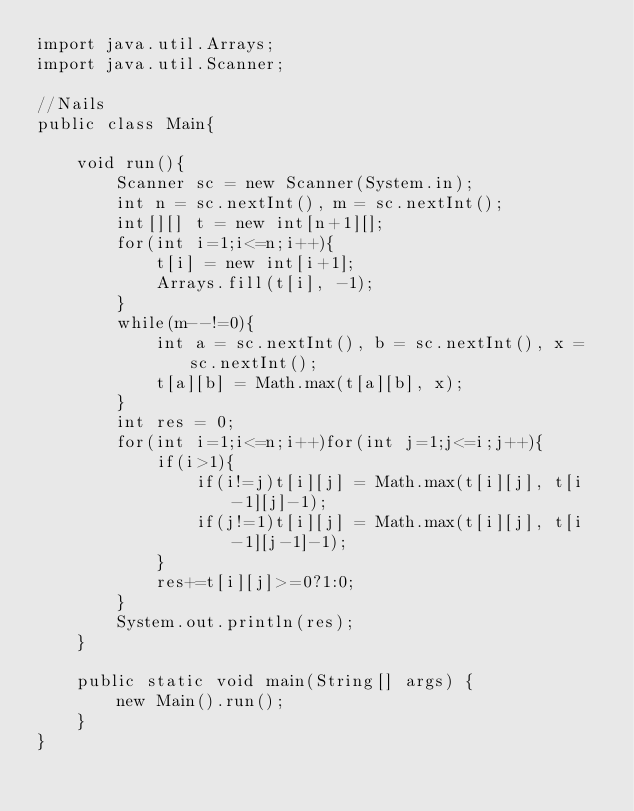Convert code to text. <code><loc_0><loc_0><loc_500><loc_500><_Java_>import java.util.Arrays;
import java.util.Scanner;

//Nails
public class Main{

	void run(){
		Scanner sc = new Scanner(System.in);
		int n = sc.nextInt(), m = sc.nextInt();
		int[][] t = new int[n+1][];
		for(int i=1;i<=n;i++){
			t[i] = new int[i+1];
			Arrays.fill(t[i], -1);
		}
		while(m--!=0){
			int a = sc.nextInt(), b = sc.nextInt(), x = sc.nextInt();
			t[a][b] = Math.max(t[a][b], x);
		}
		int res = 0;
		for(int i=1;i<=n;i++)for(int j=1;j<=i;j++){
			if(i>1){
				if(i!=j)t[i][j] = Math.max(t[i][j], t[i-1][j]-1);
				if(j!=1)t[i][j] = Math.max(t[i][j], t[i-1][j-1]-1);
			}
			res+=t[i][j]>=0?1:0;
		}
		System.out.println(res);
	}

	public static void main(String[] args) {
		new Main().run();
	}
}</code> 